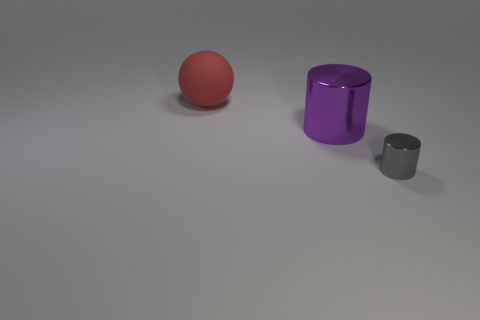Is there any other thing that is the same size as the gray cylinder?
Provide a succinct answer. No. There is a cylinder that is the same size as the red rubber thing; what material is it?
Provide a short and direct response. Metal. How many metallic things are either small gray things or big balls?
Your answer should be very brief. 1. There is a object that is to the right of the red object and behind the tiny gray thing; what is its color?
Your answer should be very brief. Purple. How many large shiny cylinders are to the left of the rubber sphere?
Make the answer very short. 0. What is the big cylinder made of?
Your answer should be very brief. Metal. There is a metal cylinder right of the large object that is in front of the sphere behind the small object; what is its color?
Provide a succinct answer. Gray. How many red things are the same size as the gray shiny thing?
Your answer should be very brief. 0. What color is the big thing that is in front of the red rubber thing?
Offer a terse response. Purple. How many other objects are there of the same size as the purple metal thing?
Make the answer very short. 1. 